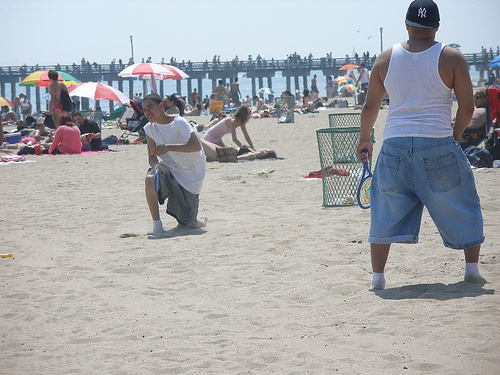Describe the objects in this image and their specific colors. I can see people in lavender, gray, and blue tones, people in lavender, gray, darkgray, and lightgray tones, people in lavender, gray, darkgray, lightgray, and black tones, people in lavender, gray, and darkgray tones, and umbrella in lavender, lightpink, darkgray, and gray tones in this image. 